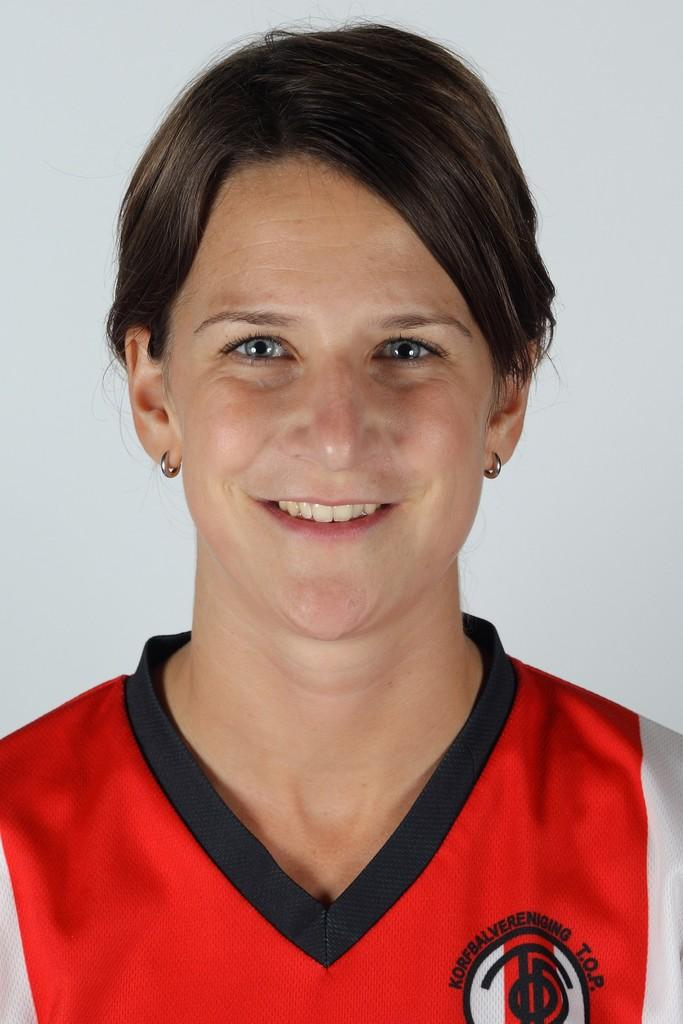Who is the main subject in the image? There is a lady in the image. What is the lady wearing? The lady is wearing a red dress. Are there any accessories visible in the image? Yes, the lady is wearing earrings. What is the color of the lady's hair? The lady has black hair. What is the lady's facial expression in the image? The lady is smiling. What disease is the lady suffering from in the image? There is no indication in the image that the lady is suffering from any disease. 